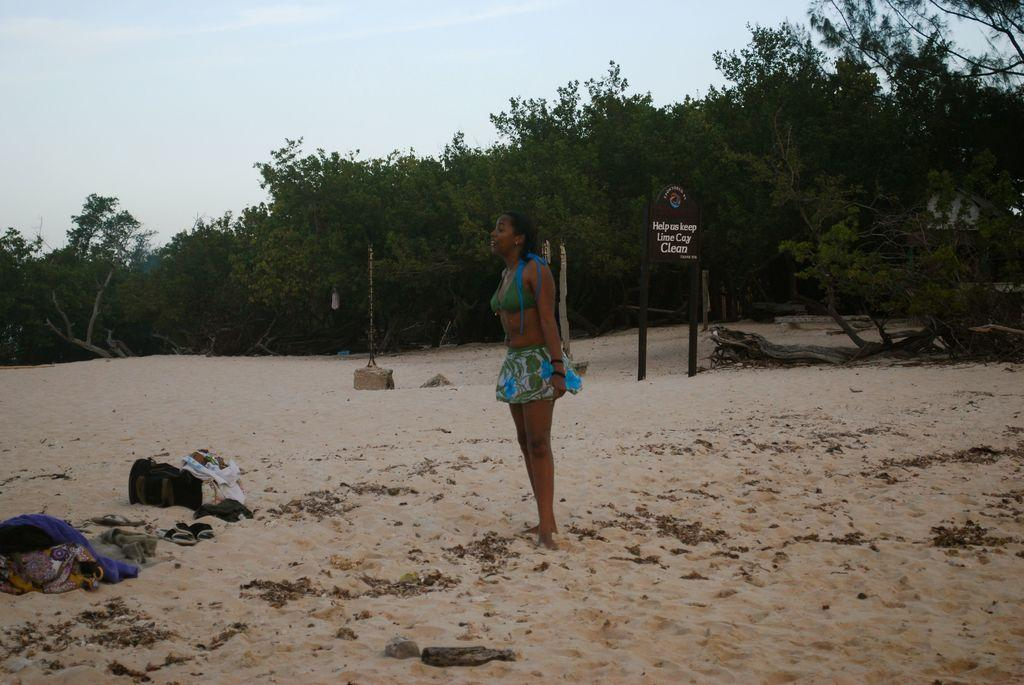What is the primary subject in the image? There is a woman standing in the image. What is the woman holding in the image? There is a bag in the image. What type of items can be seen near the woman? There are clothes and footwear in the image. What is the setting of the image? There are objects on sand in the image, and trees and the sky are visible in the background. What type of tongue can be seen sticking out in the image? There is no tongue sticking out in the image. How does the woman express her disgust in the image? There is no indication of disgust in the image. 